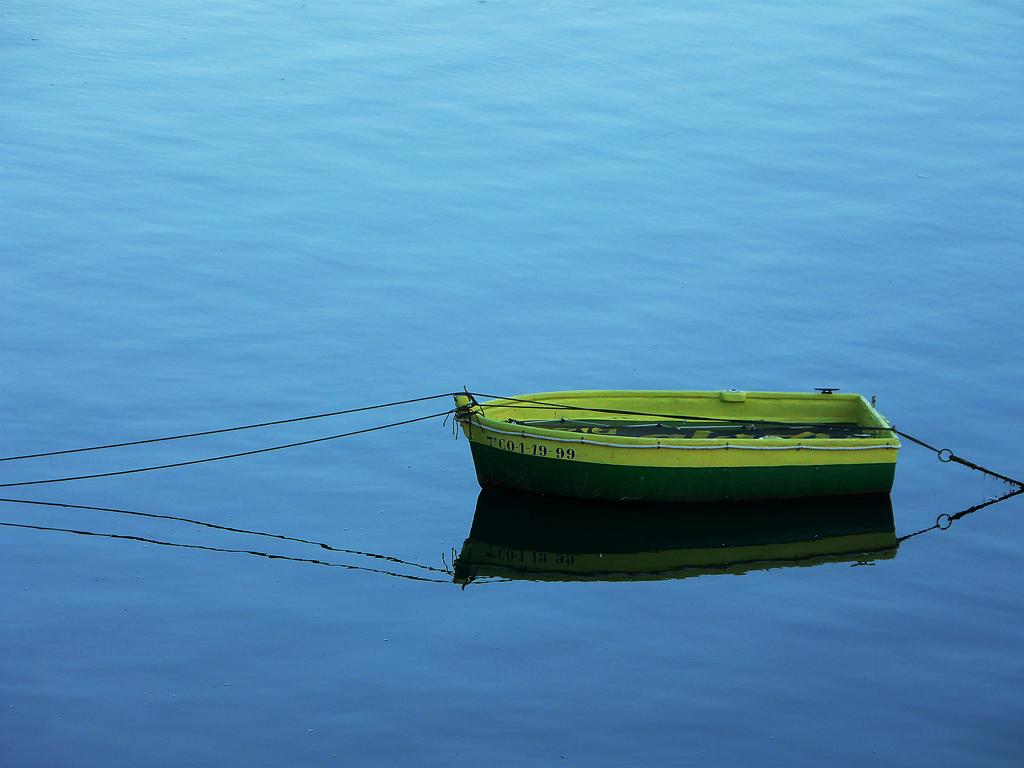What is the main subject of the image? The main subject of the image is a boat. What color is the boat? The boat is green in color. What can be seen in the background of the image? There is water visible in the image. How is the boat secured in the image? The boat is tied with a rope. Can you tell me how many linen sheets are on the boat in the image? There is no mention of linen sheets in the image; it only features a green boat tied with a rope. What type of ocean can be seen in the image? The image does not depict an ocean; it only shows a boat on water. 